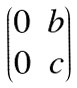Convert formula to latex. <formula><loc_0><loc_0><loc_500><loc_500>\begin{pmatrix} 0 & b \\ 0 & c \end{pmatrix}</formula> 